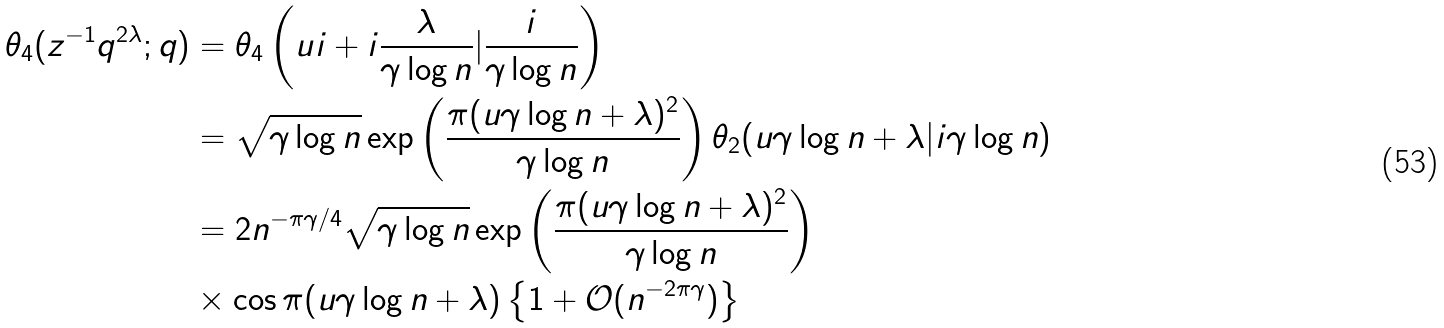Convert formula to latex. <formula><loc_0><loc_0><loc_500><loc_500>\theta _ { 4 } ( z ^ { - 1 } q ^ { 2 \lambda } ; q ) & = \theta _ { 4 } \left ( u i + i \frac { \lambda } { \gamma \log n } | \frac { i } { \gamma \log n } \right ) \\ & = \sqrt { \gamma \log n } \exp \left ( \frac { \pi ( u \gamma \log n + \lambda ) ^ { 2 } } { \gamma \log n } \right ) \theta _ { 2 } ( u \gamma \log n + \lambda | i \gamma \log n ) \\ & = 2 n ^ { - \pi \gamma / 4 } \sqrt { \gamma \log n } \exp \left ( \frac { \pi ( u \gamma \log n + \lambda ) ^ { 2 } } { \gamma \log n } \right ) \\ & \times \cos \pi ( u \gamma \log n + \lambda ) \left \{ 1 + \mathcal { O } ( n ^ { - 2 \pi \gamma } ) \right \}</formula> 